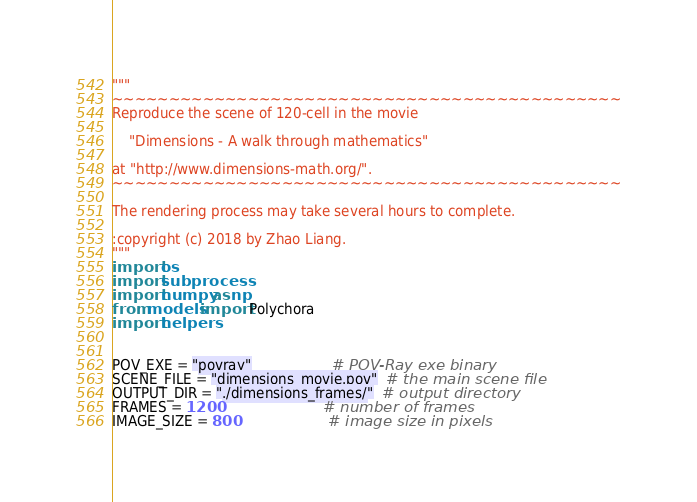<code> <loc_0><loc_0><loc_500><loc_500><_Python_>"""
~~~~~~~~~~~~~~~~~~~~~~~~~~~~~~~~~~~~~~~~~~~~~
Reproduce the scene of 120-cell in the movie

    "Dimensions - A walk through mathematics"

at "http://www.dimensions-math.org/".
~~~~~~~~~~~~~~~~~~~~~~~~~~~~~~~~~~~~~~~~~~~~~

The rendering process may take several hours to complete.

:copyright (c) 2018 by Zhao Liang.
"""
import os
import subprocess
import numpy as np
from models import Polychora
import helpers


POV_EXE = "povray"                   # POV-Ray exe binary
SCENE_FILE = "dimensions_movie.pov"  # the main scene file
OUTPUT_DIR = "./dimensions_frames/"  # output directory
FRAMES = 1200                        # number of frames
IMAGE_SIZE = 800                     # image size in pixels</code> 